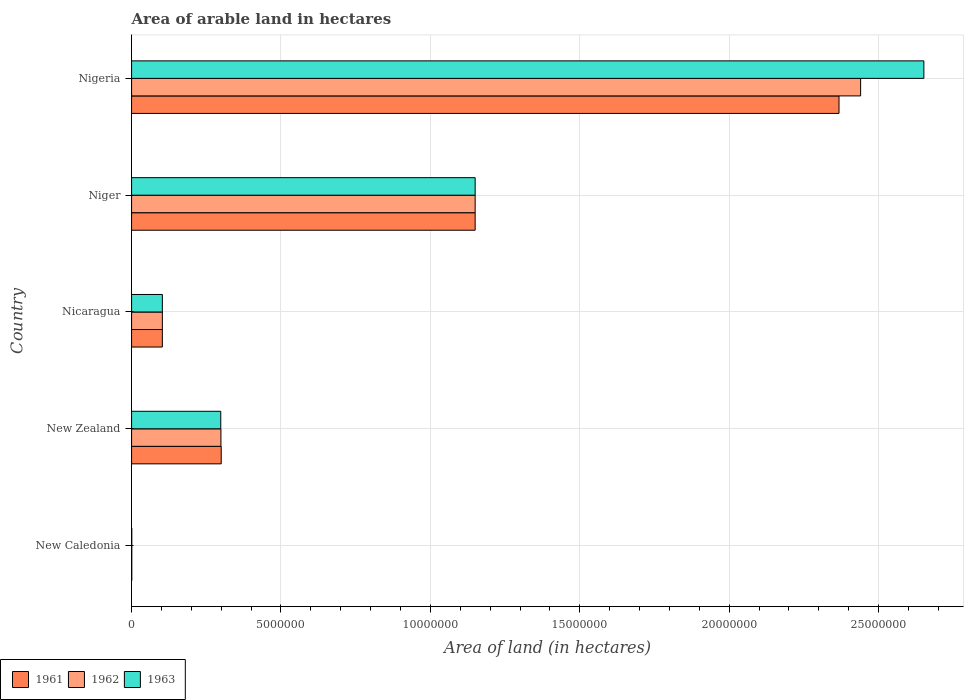How many different coloured bars are there?
Keep it short and to the point. 3. How many groups of bars are there?
Ensure brevity in your answer.  5. Are the number of bars per tick equal to the number of legend labels?
Give a very brief answer. Yes. Are the number of bars on each tick of the Y-axis equal?
Your response must be concise. Yes. How many bars are there on the 1st tick from the top?
Keep it short and to the point. 3. How many bars are there on the 3rd tick from the bottom?
Make the answer very short. 3. What is the label of the 2nd group of bars from the top?
Give a very brief answer. Niger. What is the total arable land in 1961 in New Caledonia?
Give a very brief answer. 7000. Across all countries, what is the maximum total arable land in 1963?
Make the answer very short. 2.65e+07. Across all countries, what is the minimum total arable land in 1961?
Offer a terse response. 7000. In which country was the total arable land in 1962 maximum?
Your answer should be compact. Nigeria. In which country was the total arable land in 1963 minimum?
Provide a succinct answer. New Caledonia. What is the total total arable land in 1962 in the graph?
Ensure brevity in your answer.  3.99e+07. What is the difference between the total arable land in 1963 in New Zealand and that in Nigeria?
Provide a succinct answer. -2.35e+07. What is the difference between the total arable land in 1963 in Niger and the total arable land in 1962 in Nigeria?
Provide a succinct answer. -1.29e+07. What is the average total arable land in 1963 per country?
Offer a terse response. 8.41e+06. What is the difference between the total arable land in 1962 and total arable land in 1963 in Nigeria?
Provide a succinct answer. -2.12e+06. What is the ratio of the total arable land in 1962 in New Caledonia to that in Nigeria?
Your answer should be very brief. 0. What is the difference between the highest and the second highest total arable land in 1962?
Your response must be concise. 1.29e+07. What is the difference between the highest and the lowest total arable land in 1961?
Keep it short and to the point. 2.37e+07. In how many countries, is the total arable land in 1962 greater than the average total arable land in 1962 taken over all countries?
Keep it short and to the point. 2. Is the sum of the total arable land in 1963 in New Caledonia and New Zealand greater than the maximum total arable land in 1961 across all countries?
Make the answer very short. No. How many bars are there?
Offer a very short reply. 15. Does the graph contain grids?
Make the answer very short. Yes. What is the title of the graph?
Your answer should be very brief. Area of arable land in hectares. Does "2015" appear as one of the legend labels in the graph?
Provide a short and direct response. No. What is the label or title of the X-axis?
Give a very brief answer. Area of land (in hectares). What is the Area of land (in hectares) of 1961 in New Caledonia?
Give a very brief answer. 7000. What is the Area of land (in hectares) in 1962 in New Caledonia?
Keep it short and to the point. 7000. What is the Area of land (in hectares) in 1963 in New Caledonia?
Ensure brevity in your answer.  7000. What is the Area of land (in hectares) of 1961 in New Zealand?
Your answer should be compact. 3.00e+06. What is the Area of land (in hectares) of 1962 in New Zealand?
Offer a very short reply. 2.99e+06. What is the Area of land (in hectares) in 1963 in New Zealand?
Offer a terse response. 2.98e+06. What is the Area of land (in hectares) of 1961 in Nicaragua?
Offer a terse response. 1.03e+06. What is the Area of land (in hectares) in 1962 in Nicaragua?
Make the answer very short. 1.03e+06. What is the Area of land (in hectares) of 1963 in Nicaragua?
Give a very brief answer. 1.03e+06. What is the Area of land (in hectares) in 1961 in Niger?
Your answer should be compact. 1.15e+07. What is the Area of land (in hectares) of 1962 in Niger?
Give a very brief answer. 1.15e+07. What is the Area of land (in hectares) of 1963 in Niger?
Give a very brief answer. 1.15e+07. What is the Area of land (in hectares) in 1961 in Nigeria?
Give a very brief answer. 2.37e+07. What is the Area of land (in hectares) of 1962 in Nigeria?
Provide a succinct answer. 2.44e+07. What is the Area of land (in hectares) of 1963 in Nigeria?
Give a very brief answer. 2.65e+07. Across all countries, what is the maximum Area of land (in hectares) in 1961?
Give a very brief answer. 2.37e+07. Across all countries, what is the maximum Area of land (in hectares) in 1962?
Offer a very short reply. 2.44e+07. Across all countries, what is the maximum Area of land (in hectares) in 1963?
Provide a succinct answer. 2.65e+07. Across all countries, what is the minimum Area of land (in hectares) in 1961?
Your answer should be very brief. 7000. Across all countries, what is the minimum Area of land (in hectares) of 1962?
Your answer should be compact. 7000. Across all countries, what is the minimum Area of land (in hectares) of 1963?
Make the answer very short. 7000. What is the total Area of land (in hectares) in 1961 in the graph?
Offer a terse response. 3.92e+07. What is the total Area of land (in hectares) of 1962 in the graph?
Keep it short and to the point. 3.99e+07. What is the total Area of land (in hectares) of 1963 in the graph?
Provide a succinct answer. 4.20e+07. What is the difference between the Area of land (in hectares) of 1961 in New Caledonia and that in New Zealand?
Offer a very short reply. -2.99e+06. What is the difference between the Area of land (in hectares) in 1962 in New Caledonia and that in New Zealand?
Offer a terse response. -2.98e+06. What is the difference between the Area of land (in hectares) of 1963 in New Caledonia and that in New Zealand?
Your response must be concise. -2.98e+06. What is the difference between the Area of land (in hectares) in 1961 in New Caledonia and that in Nicaragua?
Ensure brevity in your answer.  -1.02e+06. What is the difference between the Area of land (in hectares) of 1962 in New Caledonia and that in Nicaragua?
Your answer should be compact. -1.02e+06. What is the difference between the Area of land (in hectares) of 1963 in New Caledonia and that in Nicaragua?
Offer a very short reply. -1.02e+06. What is the difference between the Area of land (in hectares) of 1961 in New Caledonia and that in Niger?
Make the answer very short. -1.15e+07. What is the difference between the Area of land (in hectares) in 1962 in New Caledonia and that in Niger?
Your response must be concise. -1.15e+07. What is the difference between the Area of land (in hectares) of 1963 in New Caledonia and that in Niger?
Your response must be concise. -1.15e+07. What is the difference between the Area of land (in hectares) of 1961 in New Caledonia and that in Nigeria?
Keep it short and to the point. -2.37e+07. What is the difference between the Area of land (in hectares) of 1962 in New Caledonia and that in Nigeria?
Offer a very short reply. -2.44e+07. What is the difference between the Area of land (in hectares) in 1963 in New Caledonia and that in Nigeria?
Ensure brevity in your answer.  -2.65e+07. What is the difference between the Area of land (in hectares) in 1961 in New Zealand and that in Nicaragua?
Offer a terse response. 1.97e+06. What is the difference between the Area of land (in hectares) in 1962 in New Zealand and that in Nicaragua?
Ensure brevity in your answer.  1.96e+06. What is the difference between the Area of land (in hectares) in 1963 in New Zealand and that in Nicaragua?
Provide a short and direct response. 1.96e+06. What is the difference between the Area of land (in hectares) in 1961 in New Zealand and that in Niger?
Keep it short and to the point. -8.50e+06. What is the difference between the Area of land (in hectares) of 1962 in New Zealand and that in Niger?
Offer a terse response. -8.51e+06. What is the difference between the Area of land (in hectares) of 1963 in New Zealand and that in Niger?
Ensure brevity in your answer.  -8.51e+06. What is the difference between the Area of land (in hectares) in 1961 in New Zealand and that in Nigeria?
Provide a short and direct response. -2.07e+07. What is the difference between the Area of land (in hectares) in 1962 in New Zealand and that in Nigeria?
Offer a very short reply. -2.14e+07. What is the difference between the Area of land (in hectares) in 1963 in New Zealand and that in Nigeria?
Make the answer very short. -2.35e+07. What is the difference between the Area of land (in hectares) in 1961 in Nicaragua and that in Niger?
Provide a succinct answer. -1.05e+07. What is the difference between the Area of land (in hectares) in 1962 in Nicaragua and that in Niger?
Offer a very short reply. -1.05e+07. What is the difference between the Area of land (in hectares) of 1963 in Nicaragua and that in Niger?
Offer a very short reply. -1.05e+07. What is the difference between the Area of land (in hectares) in 1961 in Nicaragua and that in Nigeria?
Provide a succinct answer. -2.26e+07. What is the difference between the Area of land (in hectares) in 1962 in Nicaragua and that in Nigeria?
Keep it short and to the point. -2.34e+07. What is the difference between the Area of land (in hectares) of 1963 in Nicaragua and that in Nigeria?
Your response must be concise. -2.55e+07. What is the difference between the Area of land (in hectares) of 1961 in Niger and that in Nigeria?
Offer a terse response. -1.22e+07. What is the difference between the Area of land (in hectares) in 1962 in Niger and that in Nigeria?
Provide a succinct answer. -1.29e+07. What is the difference between the Area of land (in hectares) in 1963 in Niger and that in Nigeria?
Offer a very short reply. -1.50e+07. What is the difference between the Area of land (in hectares) in 1961 in New Caledonia and the Area of land (in hectares) in 1962 in New Zealand?
Ensure brevity in your answer.  -2.98e+06. What is the difference between the Area of land (in hectares) of 1961 in New Caledonia and the Area of land (in hectares) of 1963 in New Zealand?
Keep it short and to the point. -2.98e+06. What is the difference between the Area of land (in hectares) in 1962 in New Caledonia and the Area of land (in hectares) in 1963 in New Zealand?
Provide a succinct answer. -2.98e+06. What is the difference between the Area of land (in hectares) in 1961 in New Caledonia and the Area of land (in hectares) in 1962 in Nicaragua?
Ensure brevity in your answer.  -1.02e+06. What is the difference between the Area of land (in hectares) in 1961 in New Caledonia and the Area of land (in hectares) in 1963 in Nicaragua?
Make the answer very short. -1.02e+06. What is the difference between the Area of land (in hectares) of 1962 in New Caledonia and the Area of land (in hectares) of 1963 in Nicaragua?
Ensure brevity in your answer.  -1.02e+06. What is the difference between the Area of land (in hectares) of 1961 in New Caledonia and the Area of land (in hectares) of 1962 in Niger?
Your answer should be compact. -1.15e+07. What is the difference between the Area of land (in hectares) of 1961 in New Caledonia and the Area of land (in hectares) of 1963 in Niger?
Give a very brief answer. -1.15e+07. What is the difference between the Area of land (in hectares) in 1962 in New Caledonia and the Area of land (in hectares) in 1963 in Niger?
Your answer should be very brief. -1.15e+07. What is the difference between the Area of land (in hectares) of 1961 in New Caledonia and the Area of land (in hectares) of 1962 in Nigeria?
Ensure brevity in your answer.  -2.44e+07. What is the difference between the Area of land (in hectares) of 1961 in New Caledonia and the Area of land (in hectares) of 1963 in Nigeria?
Make the answer very short. -2.65e+07. What is the difference between the Area of land (in hectares) in 1962 in New Caledonia and the Area of land (in hectares) in 1963 in Nigeria?
Make the answer very short. -2.65e+07. What is the difference between the Area of land (in hectares) of 1961 in New Zealand and the Area of land (in hectares) of 1962 in Nicaragua?
Make the answer very short. 1.97e+06. What is the difference between the Area of land (in hectares) of 1961 in New Zealand and the Area of land (in hectares) of 1963 in Nicaragua?
Make the answer very short. 1.97e+06. What is the difference between the Area of land (in hectares) in 1962 in New Zealand and the Area of land (in hectares) in 1963 in Nicaragua?
Your answer should be compact. 1.96e+06. What is the difference between the Area of land (in hectares) of 1961 in New Zealand and the Area of land (in hectares) of 1962 in Niger?
Keep it short and to the point. -8.50e+06. What is the difference between the Area of land (in hectares) of 1961 in New Zealand and the Area of land (in hectares) of 1963 in Niger?
Offer a very short reply. -8.50e+06. What is the difference between the Area of land (in hectares) of 1962 in New Zealand and the Area of land (in hectares) of 1963 in Niger?
Offer a terse response. -8.51e+06. What is the difference between the Area of land (in hectares) of 1961 in New Zealand and the Area of land (in hectares) of 1962 in Nigeria?
Offer a very short reply. -2.14e+07. What is the difference between the Area of land (in hectares) of 1961 in New Zealand and the Area of land (in hectares) of 1963 in Nigeria?
Your answer should be very brief. -2.35e+07. What is the difference between the Area of land (in hectares) in 1962 in New Zealand and the Area of land (in hectares) in 1963 in Nigeria?
Make the answer very short. -2.35e+07. What is the difference between the Area of land (in hectares) of 1961 in Nicaragua and the Area of land (in hectares) of 1962 in Niger?
Ensure brevity in your answer.  -1.05e+07. What is the difference between the Area of land (in hectares) in 1961 in Nicaragua and the Area of land (in hectares) in 1963 in Niger?
Keep it short and to the point. -1.05e+07. What is the difference between the Area of land (in hectares) in 1962 in Nicaragua and the Area of land (in hectares) in 1963 in Niger?
Give a very brief answer. -1.05e+07. What is the difference between the Area of land (in hectares) of 1961 in Nicaragua and the Area of land (in hectares) of 1962 in Nigeria?
Offer a terse response. -2.34e+07. What is the difference between the Area of land (in hectares) of 1961 in Nicaragua and the Area of land (in hectares) of 1963 in Nigeria?
Make the answer very short. -2.55e+07. What is the difference between the Area of land (in hectares) in 1962 in Nicaragua and the Area of land (in hectares) in 1963 in Nigeria?
Your answer should be compact. -2.55e+07. What is the difference between the Area of land (in hectares) in 1961 in Niger and the Area of land (in hectares) in 1962 in Nigeria?
Ensure brevity in your answer.  -1.29e+07. What is the difference between the Area of land (in hectares) in 1961 in Niger and the Area of land (in hectares) in 1963 in Nigeria?
Keep it short and to the point. -1.50e+07. What is the difference between the Area of land (in hectares) of 1962 in Niger and the Area of land (in hectares) of 1963 in Nigeria?
Your answer should be compact. -1.50e+07. What is the average Area of land (in hectares) in 1961 per country?
Offer a terse response. 7.84e+06. What is the average Area of land (in hectares) in 1962 per country?
Offer a very short reply. 7.99e+06. What is the average Area of land (in hectares) of 1963 per country?
Give a very brief answer. 8.41e+06. What is the difference between the Area of land (in hectares) of 1961 and Area of land (in hectares) of 1963 in New Caledonia?
Your response must be concise. 0. What is the difference between the Area of land (in hectares) in 1962 and Area of land (in hectares) in 1963 in New Caledonia?
Your answer should be compact. 0. What is the difference between the Area of land (in hectares) in 1961 and Area of land (in hectares) in 1963 in New Zealand?
Offer a very short reply. 1.50e+04. What is the difference between the Area of land (in hectares) of 1961 and Area of land (in hectares) of 1962 in Nicaragua?
Provide a short and direct response. 0. What is the difference between the Area of land (in hectares) of 1962 and Area of land (in hectares) of 1963 in Nicaragua?
Give a very brief answer. 0. What is the difference between the Area of land (in hectares) in 1961 and Area of land (in hectares) in 1962 in Nigeria?
Provide a succinct answer. -7.23e+05. What is the difference between the Area of land (in hectares) of 1961 and Area of land (in hectares) of 1963 in Nigeria?
Make the answer very short. -2.84e+06. What is the difference between the Area of land (in hectares) in 1962 and Area of land (in hectares) in 1963 in Nigeria?
Provide a succinct answer. -2.12e+06. What is the ratio of the Area of land (in hectares) of 1961 in New Caledonia to that in New Zealand?
Provide a succinct answer. 0. What is the ratio of the Area of land (in hectares) of 1962 in New Caledonia to that in New Zealand?
Keep it short and to the point. 0. What is the ratio of the Area of land (in hectares) in 1963 in New Caledonia to that in New Zealand?
Give a very brief answer. 0. What is the ratio of the Area of land (in hectares) of 1961 in New Caledonia to that in Nicaragua?
Keep it short and to the point. 0.01. What is the ratio of the Area of land (in hectares) in 1962 in New Caledonia to that in Nicaragua?
Offer a terse response. 0.01. What is the ratio of the Area of land (in hectares) in 1963 in New Caledonia to that in Nicaragua?
Keep it short and to the point. 0.01. What is the ratio of the Area of land (in hectares) in 1961 in New Caledonia to that in Niger?
Your answer should be compact. 0. What is the ratio of the Area of land (in hectares) in 1962 in New Caledonia to that in Niger?
Ensure brevity in your answer.  0. What is the ratio of the Area of land (in hectares) in 1963 in New Caledonia to that in Niger?
Offer a very short reply. 0. What is the ratio of the Area of land (in hectares) in 1962 in New Caledonia to that in Nigeria?
Offer a very short reply. 0. What is the ratio of the Area of land (in hectares) in 1963 in New Caledonia to that in Nigeria?
Keep it short and to the point. 0. What is the ratio of the Area of land (in hectares) in 1961 in New Zealand to that in Nicaragua?
Keep it short and to the point. 2.91. What is the ratio of the Area of land (in hectares) in 1962 in New Zealand to that in Nicaragua?
Keep it short and to the point. 2.9. What is the ratio of the Area of land (in hectares) in 1963 in New Zealand to that in Nicaragua?
Your response must be concise. 2.9. What is the ratio of the Area of land (in hectares) of 1961 in New Zealand to that in Niger?
Offer a very short reply. 0.26. What is the ratio of the Area of land (in hectares) of 1962 in New Zealand to that in Niger?
Your answer should be very brief. 0.26. What is the ratio of the Area of land (in hectares) of 1963 in New Zealand to that in Niger?
Give a very brief answer. 0.26. What is the ratio of the Area of land (in hectares) in 1961 in New Zealand to that in Nigeria?
Ensure brevity in your answer.  0.13. What is the ratio of the Area of land (in hectares) of 1962 in New Zealand to that in Nigeria?
Your answer should be compact. 0.12. What is the ratio of the Area of land (in hectares) of 1963 in New Zealand to that in Nigeria?
Provide a short and direct response. 0.11. What is the ratio of the Area of land (in hectares) in 1961 in Nicaragua to that in Niger?
Make the answer very short. 0.09. What is the ratio of the Area of land (in hectares) in 1962 in Nicaragua to that in Niger?
Offer a terse response. 0.09. What is the ratio of the Area of land (in hectares) of 1963 in Nicaragua to that in Niger?
Give a very brief answer. 0.09. What is the ratio of the Area of land (in hectares) in 1961 in Nicaragua to that in Nigeria?
Keep it short and to the point. 0.04. What is the ratio of the Area of land (in hectares) of 1962 in Nicaragua to that in Nigeria?
Your answer should be compact. 0.04. What is the ratio of the Area of land (in hectares) of 1963 in Nicaragua to that in Nigeria?
Provide a short and direct response. 0.04. What is the ratio of the Area of land (in hectares) of 1961 in Niger to that in Nigeria?
Keep it short and to the point. 0.49. What is the ratio of the Area of land (in hectares) in 1962 in Niger to that in Nigeria?
Ensure brevity in your answer.  0.47. What is the ratio of the Area of land (in hectares) of 1963 in Niger to that in Nigeria?
Ensure brevity in your answer.  0.43. What is the difference between the highest and the second highest Area of land (in hectares) in 1961?
Your answer should be very brief. 1.22e+07. What is the difference between the highest and the second highest Area of land (in hectares) in 1962?
Ensure brevity in your answer.  1.29e+07. What is the difference between the highest and the second highest Area of land (in hectares) of 1963?
Provide a short and direct response. 1.50e+07. What is the difference between the highest and the lowest Area of land (in hectares) of 1961?
Provide a short and direct response. 2.37e+07. What is the difference between the highest and the lowest Area of land (in hectares) in 1962?
Your answer should be very brief. 2.44e+07. What is the difference between the highest and the lowest Area of land (in hectares) in 1963?
Your answer should be compact. 2.65e+07. 